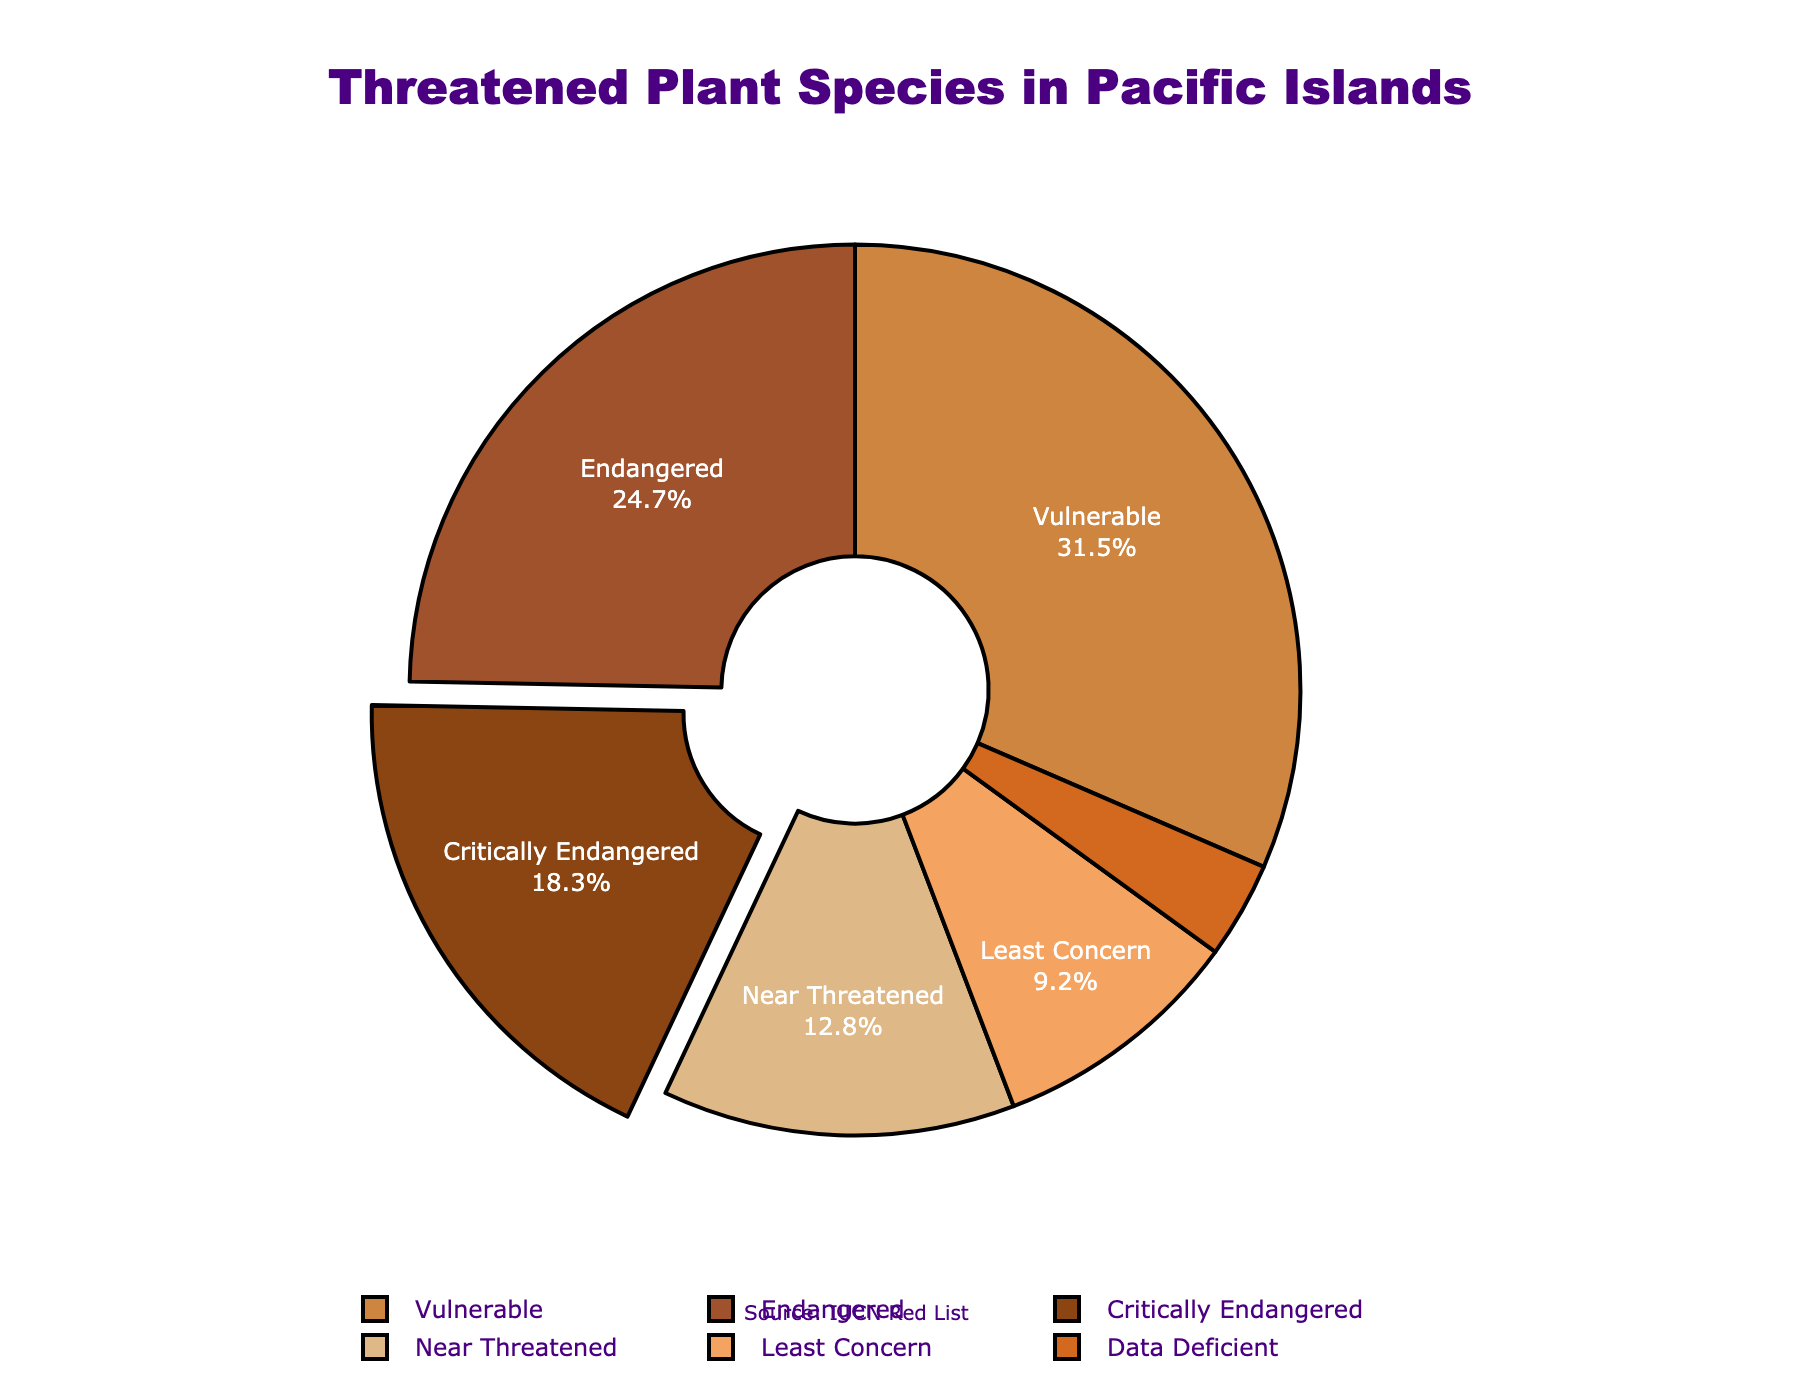What proportion of plant species are classified as Endangered or Vulnerable? The pie chart shows that 24.7% of plant species are classified as Endangered and 31.5% as Vulnerable. Adding these two percentages together gives 24.7 + 31.5 = 56.2%
Answer: 56.2% Which IUCN Red List category has the smallest proportion of plant species? By looking at the pie chart, the Data Deficient category has the smallest slice, representing 3.5% of the total.
Answer: Data Deficient How much larger is the percentage of Vulnerable plant species compared to Critically Endangered plant species? The pie chart shows 31.5% for Vulnerable and 18.3% for Critically Endangered. The difference is 31.5 - 18.3 = 13.2%
Answer: 13.2% Which categories combined constitute more than half of the threatened plant species? Adding the percentages for Vulnerable (31.5%), Endangered (24.7%), Near Threatened (12.8%), and Critically Endangered (18.3%) categories: 31.5 + 24.7 + 12.8 + 18.3 = 87.3%. These categories all combined are more than half the total.
Answer: Vulnerable, Endangered, Near Threatened, Critically Endangered Is the proportion of Least Concern plant species greater than the sum of Critically Endangered and Data Deficient species? The pie chart shows 9.2% for Least Concern, 18.3% for Critically Endangered, and 3.5% for Data Deficient. Adding Critically Endangered and Data Deficient gives 18.3 + 3.5 = 21.8%, which is greater than 9.2%.
Answer: No By what percentage does the Near Threatened category differ from the Least Concern category? According to the pie chart, Near Threatened is 12.8% and Least Concern is 9.2%. The difference is 12.8 - 9.2 = 3.6%.
Answer: 3.6% What proportion of plant species fall into the Critically Endangered, Endangered, and Vulnerable categories combined? The pie chart shows the percentages as 18.3% for Critically Endangered, 24.7% for Endangered, and 31.5% for Vulnerable. Adding these together gives 18.3 + 24.7 + 31.5 = 74.5%.
Answer: 74.5% Describe the visual highlighting of the Critically Endangered category in the pie chart. The Critically Endangered category has a larger slice separated from the main pie to emphasize its importance visually. This makes it stand out compared to other categories.
Answer: Pulled out slice What color represents the Endangered category in the pie chart? The Endangered category in the pie chart is represented by the second color in the palette, which is brown.
Answer: Brown What is the average proportion of plant species in the Endangered and Near Threatened categories? According to the chart, Endangered has 24.7% and Near Threatened has 12.8%. The average is (24.7 + 12.8) / 2 = 18.75%.
Answer: 18.75% 